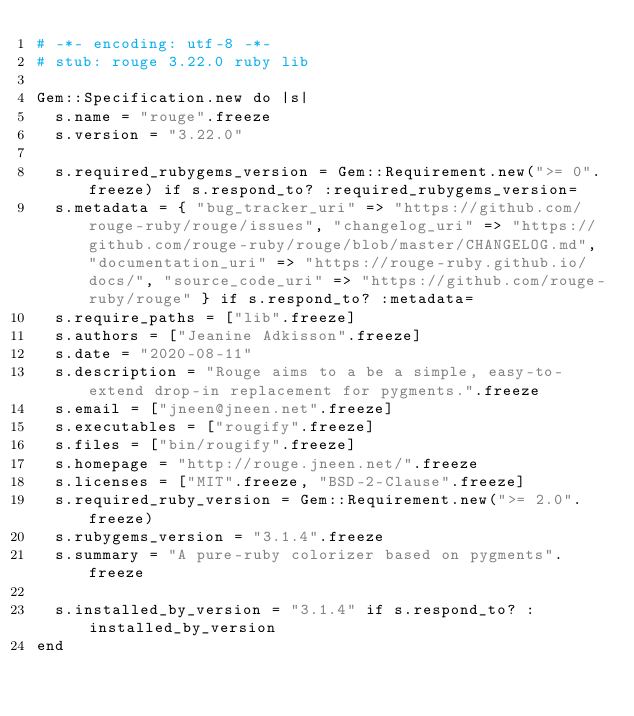<code> <loc_0><loc_0><loc_500><loc_500><_Ruby_># -*- encoding: utf-8 -*-
# stub: rouge 3.22.0 ruby lib

Gem::Specification.new do |s|
  s.name = "rouge".freeze
  s.version = "3.22.0"

  s.required_rubygems_version = Gem::Requirement.new(">= 0".freeze) if s.respond_to? :required_rubygems_version=
  s.metadata = { "bug_tracker_uri" => "https://github.com/rouge-ruby/rouge/issues", "changelog_uri" => "https://github.com/rouge-ruby/rouge/blob/master/CHANGELOG.md", "documentation_uri" => "https://rouge-ruby.github.io/docs/", "source_code_uri" => "https://github.com/rouge-ruby/rouge" } if s.respond_to? :metadata=
  s.require_paths = ["lib".freeze]
  s.authors = ["Jeanine Adkisson".freeze]
  s.date = "2020-08-11"
  s.description = "Rouge aims to a be a simple, easy-to-extend drop-in replacement for pygments.".freeze
  s.email = ["jneen@jneen.net".freeze]
  s.executables = ["rougify".freeze]
  s.files = ["bin/rougify".freeze]
  s.homepage = "http://rouge.jneen.net/".freeze
  s.licenses = ["MIT".freeze, "BSD-2-Clause".freeze]
  s.required_ruby_version = Gem::Requirement.new(">= 2.0".freeze)
  s.rubygems_version = "3.1.4".freeze
  s.summary = "A pure-ruby colorizer based on pygments".freeze

  s.installed_by_version = "3.1.4" if s.respond_to? :installed_by_version
end
</code> 